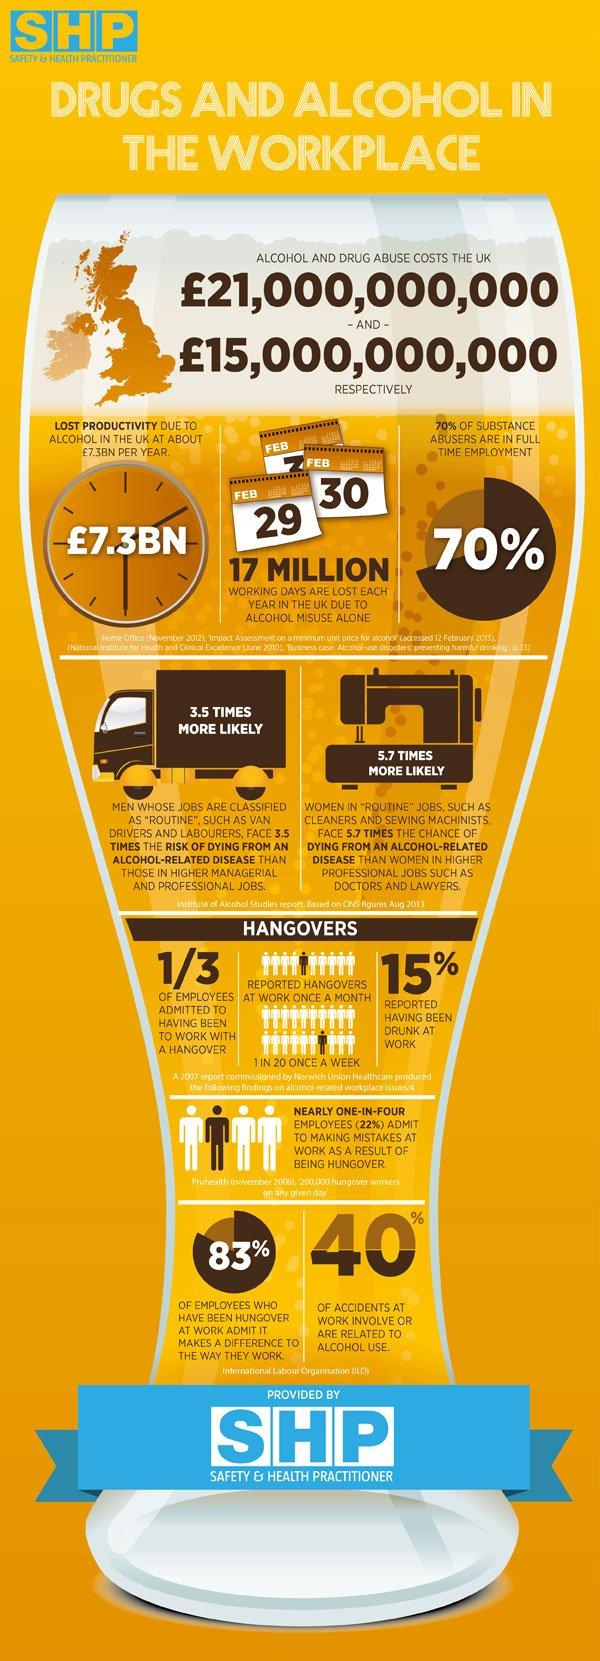Outline some significant characteristics in this image. There are three calendars depicted in this infographic. There is only one clock depicted in this infographic. According to a recent study, approximately 30% of substance abusers are not in full-time employment. Approximately 60% of accidents do not involve the use of alcohol. 